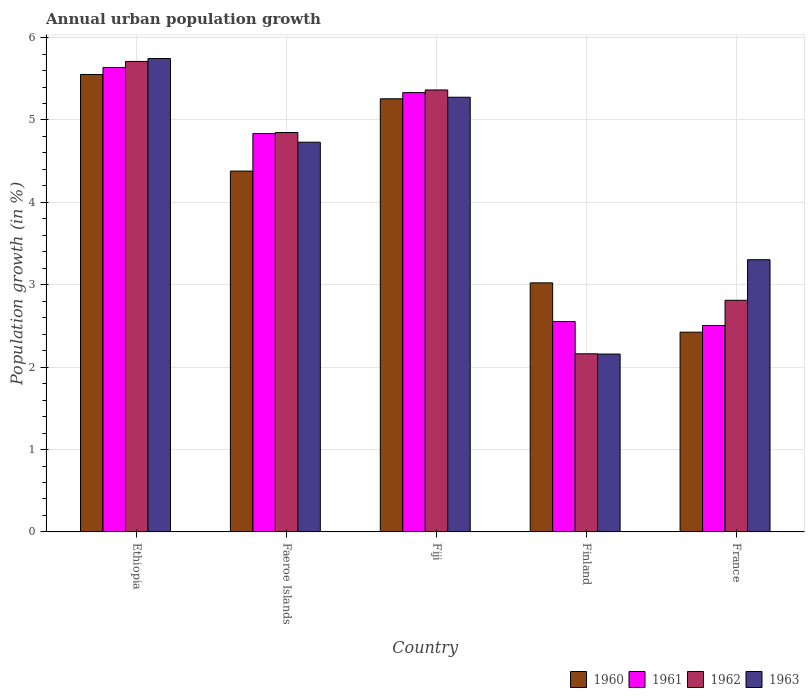How many different coloured bars are there?
Provide a succinct answer. 4. Are the number of bars on each tick of the X-axis equal?
Ensure brevity in your answer.  Yes. How many bars are there on the 4th tick from the left?
Provide a short and direct response. 4. What is the label of the 3rd group of bars from the left?
Ensure brevity in your answer.  Fiji. What is the percentage of urban population growth in 1961 in Fiji?
Provide a short and direct response. 5.33. Across all countries, what is the maximum percentage of urban population growth in 1960?
Provide a succinct answer. 5.55. Across all countries, what is the minimum percentage of urban population growth in 1961?
Make the answer very short. 2.51. In which country was the percentage of urban population growth in 1963 maximum?
Offer a very short reply. Ethiopia. What is the total percentage of urban population growth in 1960 in the graph?
Your answer should be very brief. 20.64. What is the difference between the percentage of urban population growth in 1962 in Fiji and that in Finland?
Ensure brevity in your answer.  3.2. What is the difference between the percentage of urban population growth in 1960 in Ethiopia and the percentage of urban population growth in 1962 in Finland?
Offer a terse response. 3.39. What is the average percentage of urban population growth in 1963 per country?
Ensure brevity in your answer.  4.24. What is the difference between the percentage of urban population growth of/in 1961 and percentage of urban population growth of/in 1960 in Faeroe Islands?
Keep it short and to the point. 0.46. In how many countries, is the percentage of urban population growth in 1961 greater than 0.6000000000000001 %?
Offer a very short reply. 5. What is the ratio of the percentage of urban population growth in 1963 in Faeroe Islands to that in France?
Provide a succinct answer. 1.43. Is the percentage of urban population growth in 1962 in Ethiopia less than that in France?
Make the answer very short. No. Is the difference between the percentage of urban population growth in 1961 in Faeroe Islands and France greater than the difference between the percentage of urban population growth in 1960 in Faeroe Islands and France?
Make the answer very short. Yes. What is the difference between the highest and the second highest percentage of urban population growth in 1963?
Your response must be concise. 0.55. What is the difference between the highest and the lowest percentage of urban population growth in 1960?
Your answer should be compact. 3.13. In how many countries, is the percentage of urban population growth in 1960 greater than the average percentage of urban population growth in 1960 taken over all countries?
Your response must be concise. 3. Is it the case that in every country, the sum of the percentage of urban population growth in 1961 and percentage of urban population growth in 1962 is greater than the sum of percentage of urban population growth in 1960 and percentage of urban population growth in 1963?
Your answer should be very brief. No. How many bars are there?
Offer a terse response. 20. Are all the bars in the graph horizontal?
Your answer should be very brief. No. What is the difference between two consecutive major ticks on the Y-axis?
Provide a succinct answer. 1. Are the values on the major ticks of Y-axis written in scientific E-notation?
Provide a short and direct response. No. Where does the legend appear in the graph?
Provide a succinct answer. Bottom right. What is the title of the graph?
Provide a short and direct response. Annual urban population growth. Does "1970" appear as one of the legend labels in the graph?
Ensure brevity in your answer.  No. What is the label or title of the X-axis?
Provide a short and direct response. Country. What is the label or title of the Y-axis?
Offer a very short reply. Population growth (in %). What is the Population growth (in %) of 1960 in Ethiopia?
Provide a succinct answer. 5.55. What is the Population growth (in %) in 1961 in Ethiopia?
Provide a succinct answer. 5.64. What is the Population growth (in %) of 1962 in Ethiopia?
Provide a short and direct response. 5.71. What is the Population growth (in %) in 1963 in Ethiopia?
Provide a short and direct response. 5.75. What is the Population growth (in %) in 1960 in Faeroe Islands?
Offer a very short reply. 4.38. What is the Population growth (in %) of 1961 in Faeroe Islands?
Provide a short and direct response. 4.84. What is the Population growth (in %) in 1962 in Faeroe Islands?
Provide a short and direct response. 4.85. What is the Population growth (in %) in 1963 in Faeroe Islands?
Ensure brevity in your answer.  4.73. What is the Population growth (in %) of 1960 in Fiji?
Keep it short and to the point. 5.26. What is the Population growth (in %) in 1961 in Fiji?
Your response must be concise. 5.33. What is the Population growth (in %) of 1962 in Fiji?
Your answer should be very brief. 5.36. What is the Population growth (in %) of 1963 in Fiji?
Offer a terse response. 5.28. What is the Population growth (in %) in 1960 in Finland?
Offer a terse response. 3.02. What is the Population growth (in %) of 1961 in Finland?
Provide a short and direct response. 2.55. What is the Population growth (in %) of 1962 in Finland?
Your answer should be compact. 2.16. What is the Population growth (in %) in 1963 in Finland?
Ensure brevity in your answer.  2.16. What is the Population growth (in %) in 1960 in France?
Offer a very short reply. 2.42. What is the Population growth (in %) of 1961 in France?
Offer a terse response. 2.51. What is the Population growth (in %) in 1962 in France?
Give a very brief answer. 2.81. What is the Population growth (in %) of 1963 in France?
Give a very brief answer. 3.3. Across all countries, what is the maximum Population growth (in %) in 1960?
Provide a short and direct response. 5.55. Across all countries, what is the maximum Population growth (in %) of 1961?
Your response must be concise. 5.64. Across all countries, what is the maximum Population growth (in %) of 1962?
Offer a very short reply. 5.71. Across all countries, what is the maximum Population growth (in %) in 1963?
Provide a short and direct response. 5.75. Across all countries, what is the minimum Population growth (in %) of 1960?
Offer a very short reply. 2.42. Across all countries, what is the minimum Population growth (in %) in 1961?
Offer a very short reply. 2.51. Across all countries, what is the minimum Population growth (in %) of 1962?
Your answer should be compact. 2.16. Across all countries, what is the minimum Population growth (in %) in 1963?
Offer a terse response. 2.16. What is the total Population growth (in %) in 1960 in the graph?
Keep it short and to the point. 20.64. What is the total Population growth (in %) in 1961 in the graph?
Provide a succinct answer. 20.86. What is the total Population growth (in %) of 1962 in the graph?
Make the answer very short. 20.9. What is the total Population growth (in %) in 1963 in the graph?
Make the answer very short. 21.22. What is the difference between the Population growth (in %) in 1960 in Ethiopia and that in Faeroe Islands?
Keep it short and to the point. 1.17. What is the difference between the Population growth (in %) in 1961 in Ethiopia and that in Faeroe Islands?
Provide a succinct answer. 0.8. What is the difference between the Population growth (in %) of 1962 in Ethiopia and that in Faeroe Islands?
Offer a very short reply. 0.86. What is the difference between the Population growth (in %) in 1963 in Ethiopia and that in Faeroe Islands?
Give a very brief answer. 1.02. What is the difference between the Population growth (in %) in 1960 in Ethiopia and that in Fiji?
Provide a succinct answer. 0.29. What is the difference between the Population growth (in %) of 1961 in Ethiopia and that in Fiji?
Your response must be concise. 0.31. What is the difference between the Population growth (in %) of 1962 in Ethiopia and that in Fiji?
Offer a terse response. 0.35. What is the difference between the Population growth (in %) in 1963 in Ethiopia and that in Fiji?
Keep it short and to the point. 0.47. What is the difference between the Population growth (in %) of 1960 in Ethiopia and that in Finland?
Provide a short and direct response. 2.53. What is the difference between the Population growth (in %) in 1961 in Ethiopia and that in Finland?
Keep it short and to the point. 3.08. What is the difference between the Population growth (in %) in 1962 in Ethiopia and that in Finland?
Offer a terse response. 3.55. What is the difference between the Population growth (in %) of 1963 in Ethiopia and that in Finland?
Provide a short and direct response. 3.59. What is the difference between the Population growth (in %) in 1960 in Ethiopia and that in France?
Your answer should be very brief. 3.13. What is the difference between the Population growth (in %) of 1961 in Ethiopia and that in France?
Keep it short and to the point. 3.13. What is the difference between the Population growth (in %) of 1962 in Ethiopia and that in France?
Keep it short and to the point. 2.9. What is the difference between the Population growth (in %) of 1963 in Ethiopia and that in France?
Keep it short and to the point. 2.44. What is the difference between the Population growth (in %) in 1960 in Faeroe Islands and that in Fiji?
Your response must be concise. -0.88. What is the difference between the Population growth (in %) in 1961 in Faeroe Islands and that in Fiji?
Offer a terse response. -0.5. What is the difference between the Population growth (in %) of 1962 in Faeroe Islands and that in Fiji?
Provide a succinct answer. -0.52. What is the difference between the Population growth (in %) in 1963 in Faeroe Islands and that in Fiji?
Give a very brief answer. -0.55. What is the difference between the Population growth (in %) of 1960 in Faeroe Islands and that in Finland?
Provide a succinct answer. 1.36. What is the difference between the Population growth (in %) of 1961 in Faeroe Islands and that in Finland?
Ensure brevity in your answer.  2.28. What is the difference between the Population growth (in %) of 1962 in Faeroe Islands and that in Finland?
Ensure brevity in your answer.  2.69. What is the difference between the Population growth (in %) of 1963 in Faeroe Islands and that in Finland?
Keep it short and to the point. 2.57. What is the difference between the Population growth (in %) of 1960 in Faeroe Islands and that in France?
Offer a terse response. 1.96. What is the difference between the Population growth (in %) of 1961 in Faeroe Islands and that in France?
Your answer should be compact. 2.33. What is the difference between the Population growth (in %) of 1962 in Faeroe Islands and that in France?
Offer a very short reply. 2.04. What is the difference between the Population growth (in %) in 1963 in Faeroe Islands and that in France?
Provide a short and direct response. 1.43. What is the difference between the Population growth (in %) of 1960 in Fiji and that in Finland?
Provide a succinct answer. 2.23. What is the difference between the Population growth (in %) in 1961 in Fiji and that in Finland?
Provide a short and direct response. 2.78. What is the difference between the Population growth (in %) of 1962 in Fiji and that in Finland?
Give a very brief answer. 3.2. What is the difference between the Population growth (in %) of 1963 in Fiji and that in Finland?
Make the answer very short. 3.12. What is the difference between the Population growth (in %) of 1960 in Fiji and that in France?
Your answer should be compact. 2.83. What is the difference between the Population growth (in %) of 1961 in Fiji and that in France?
Provide a short and direct response. 2.83. What is the difference between the Population growth (in %) in 1962 in Fiji and that in France?
Provide a short and direct response. 2.55. What is the difference between the Population growth (in %) in 1963 in Fiji and that in France?
Your answer should be very brief. 1.97. What is the difference between the Population growth (in %) in 1960 in Finland and that in France?
Ensure brevity in your answer.  0.6. What is the difference between the Population growth (in %) in 1961 in Finland and that in France?
Offer a very short reply. 0.05. What is the difference between the Population growth (in %) of 1962 in Finland and that in France?
Make the answer very short. -0.65. What is the difference between the Population growth (in %) of 1963 in Finland and that in France?
Provide a succinct answer. -1.15. What is the difference between the Population growth (in %) of 1960 in Ethiopia and the Population growth (in %) of 1961 in Faeroe Islands?
Make the answer very short. 0.72. What is the difference between the Population growth (in %) of 1960 in Ethiopia and the Population growth (in %) of 1962 in Faeroe Islands?
Your response must be concise. 0.7. What is the difference between the Population growth (in %) in 1960 in Ethiopia and the Population growth (in %) in 1963 in Faeroe Islands?
Offer a terse response. 0.82. What is the difference between the Population growth (in %) of 1961 in Ethiopia and the Population growth (in %) of 1962 in Faeroe Islands?
Your response must be concise. 0.79. What is the difference between the Population growth (in %) of 1961 in Ethiopia and the Population growth (in %) of 1963 in Faeroe Islands?
Your response must be concise. 0.91. What is the difference between the Population growth (in %) of 1962 in Ethiopia and the Population growth (in %) of 1963 in Faeroe Islands?
Give a very brief answer. 0.98. What is the difference between the Population growth (in %) of 1960 in Ethiopia and the Population growth (in %) of 1961 in Fiji?
Ensure brevity in your answer.  0.22. What is the difference between the Population growth (in %) of 1960 in Ethiopia and the Population growth (in %) of 1962 in Fiji?
Give a very brief answer. 0.19. What is the difference between the Population growth (in %) of 1960 in Ethiopia and the Population growth (in %) of 1963 in Fiji?
Your response must be concise. 0.28. What is the difference between the Population growth (in %) of 1961 in Ethiopia and the Population growth (in %) of 1962 in Fiji?
Your response must be concise. 0.27. What is the difference between the Population growth (in %) of 1961 in Ethiopia and the Population growth (in %) of 1963 in Fiji?
Keep it short and to the point. 0.36. What is the difference between the Population growth (in %) in 1962 in Ethiopia and the Population growth (in %) in 1963 in Fiji?
Provide a succinct answer. 0.43. What is the difference between the Population growth (in %) in 1960 in Ethiopia and the Population growth (in %) in 1961 in Finland?
Offer a terse response. 3. What is the difference between the Population growth (in %) in 1960 in Ethiopia and the Population growth (in %) in 1962 in Finland?
Your answer should be compact. 3.39. What is the difference between the Population growth (in %) of 1960 in Ethiopia and the Population growth (in %) of 1963 in Finland?
Ensure brevity in your answer.  3.39. What is the difference between the Population growth (in %) of 1961 in Ethiopia and the Population growth (in %) of 1962 in Finland?
Your answer should be compact. 3.48. What is the difference between the Population growth (in %) in 1961 in Ethiopia and the Population growth (in %) in 1963 in Finland?
Provide a short and direct response. 3.48. What is the difference between the Population growth (in %) of 1962 in Ethiopia and the Population growth (in %) of 1963 in Finland?
Provide a short and direct response. 3.55. What is the difference between the Population growth (in %) in 1960 in Ethiopia and the Population growth (in %) in 1961 in France?
Your answer should be compact. 3.05. What is the difference between the Population growth (in %) in 1960 in Ethiopia and the Population growth (in %) in 1962 in France?
Your response must be concise. 2.74. What is the difference between the Population growth (in %) in 1960 in Ethiopia and the Population growth (in %) in 1963 in France?
Provide a succinct answer. 2.25. What is the difference between the Population growth (in %) in 1961 in Ethiopia and the Population growth (in %) in 1962 in France?
Your answer should be compact. 2.83. What is the difference between the Population growth (in %) of 1961 in Ethiopia and the Population growth (in %) of 1963 in France?
Keep it short and to the point. 2.33. What is the difference between the Population growth (in %) in 1962 in Ethiopia and the Population growth (in %) in 1963 in France?
Ensure brevity in your answer.  2.41. What is the difference between the Population growth (in %) of 1960 in Faeroe Islands and the Population growth (in %) of 1961 in Fiji?
Offer a terse response. -0.95. What is the difference between the Population growth (in %) in 1960 in Faeroe Islands and the Population growth (in %) in 1962 in Fiji?
Give a very brief answer. -0.98. What is the difference between the Population growth (in %) of 1960 in Faeroe Islands and the Population growth (in %) of 1963 in Fiji?
Provide a succinct answer. -0.9. What is the difference between the Population growth (in %) of 1961 in Faeroe Islands and the Population growth (in %) of 1962 in Fiji?
Offer a very short reply. -0.53. What is the difference between the Population growth (in %) in 1961 in Faeroe Islands and the Population growth (in %) in 1963 in Fiji?
Give a very brief answer. -0.44. What is the difference between the Population growth (in %) in 1962 in Faeroe Islands and the Population growth (in %) in 1963 in Fiji?
Offer a very short reply. -0.43. What is the difference between the Population growth (in %) in 1960 in Faeroe Islands and the Population growth (in %) in 1961 in Finland?
Give a very brief answer. 1.83. What is the difference between the Population growth (in %) in 1960 in Faeroe Islands and the Population growth (in %) in 1962 in Finland?
Ensure brevity in your answer.  2.22. What is the difference between the Population growth (in %) in 1960 in Faeroe Islands and the Population growth (in %) in 1963 in Finland?
Your answer should be compact. 2.22. What is the difference between the Population growth (in %) of 1961 in Faeroe Islands and the Population growth (in %) of 1962 in Finland?
Your answer should be very brief. 2.67. What is the difference between the Population growth (in %) of 1961 in Faeroe Islands and the Population growth (in %) of 1963 in Finland?
Make the answer very short. 2.68. What is the difference between the Population growth (in %) in 1962 in Faeroe Islands and the Population growth (in %) in 1963 in Finland?
Keep it short and to the point. 2.69. What is the difference between the Population growth (in %) of 1960 in Faeroe Islands and the Population growth (in %) of 1961 in France?
Your answer should be compact. 1.87. What is the difference between the Population growth (in %) of 1960 in Faeroe Islands and the Population growth (in %) of 1962 in France?
Ensure brevity in your answer.  1.57. What is the difference between the Population growth (in %) of 1960 in Faeroe Islands and the Population growth (in %) of 1963 in France?
Keep it short and to the point. 1.08. What is the difference between the Population growth (in %) in 1961 in Faeroe Islands and the Population growth (in %) in 1962 in France?
Offer a terse response. 2.02. What is the difference between the Population growth (in %) of 1961 in Faeroe Islands and the Population growth (in %) of 1963 in France?
Make the answer very short. 1.53. What is the difference between the Population growth (in %) in 1962 in Faeroe Islands and the Population growth (in %) in 1963 in France?
Keep it short and to the point. 1.54. What is the difference between the Population growth (in %) in 1960 in Fiji and the Population growth (in %) in 1961 in Finland?
Make the answer very short. 2.7. What is the difference between the Population growth (in %) in 1960 in Fiji and the Population growth (in %) in 1962 in Finland?
Ensure brevity in your answer.  3.1. What is the difference between the Population growth (in %) of 1960 in Fiji and the Population growth (in %) of 1963 in Finland?
Give a very brief answer. 3.1. What is the difference between the Population growth (in %) of 1961 in Fiji and the Population growth (in %) of 1962 in Finland?
Keep it short and to the point. 3.17. What is the difference between the Population growth (in %) of 1961 in Fiji and the Population growth (in %) of 1963 in Finland?
Your answer should be very brief. 3.17. What is the difference between the Population growth (in %) in 1962 in Fiji and the Population growth (in %) in 1963 in Finland?
Your answer should be compact. 3.21. What is the difference between the Population growth (in %) of 1960 in Fiji and the Population growth (in %) of 1961 in France?
Your answer should be very brief. 2.75. What is the difference between the Population growth (in %) in 1960 in Fiji and the Population growth (in %) in 1962 in France?
Your answer should be very brief. 2.45. What is the difference between the Population growth (in %) of 1960 in Fiji and the Population growth (in %) of 1963 in France?
Your answer should be very brief. 1.95. What is the difference between the Population growth (in %) of 1961 in Fiji and the Population growth (in %) of 1962 in France?
Your answer should be very brief. 2.52. What is the difference between the Population growth (in %) of 1961 in Fiji and the Population growth (in %) of 1963 in France?
Make the answer very short. 2.03. What is the difference between the Population growth (in %) in 1962 in Fiji and the Population growth (in %) in 1963 in France?
Offer a terse response. 2.06. What is the difference between the Population growth (in %) of 1960 in Finland and the Population growth (in %) of 1961 in France?
Make the answer very short. 0.52. What is the difference between the Population growth (in %) in 1960 in Finland and the Population growth (in %) in 1962 in France?
Keep it short and to the point. 0.21. What is the difference between the Population growth (in %) in 1960 in Finland and the Population growth (in %) in 1963 in France?
Give a very brief answer. -0.28. What is the difference between the Population growth (in %) of 1961 in Finland and the Population growth (in %) of 1962 in France?
Your answer should be compact. -0.26. What is the difference between the Population growth (in %) of 1961 in Finland and the Population growth (in %) of 1963 in France?
Keep it short and to the point. -0.75. What is the difference between the Population growth (in %) in 1962 in Finland and the Population growth (in %) in 1963 in France?
Your response must be concise. -1.14. What is the average Population growth (in %) of 1960 per country?
Provide a short and direct response. 4.13. What is the average Population growth (in %) in 1961 per country?
Make the answer very short. 4.17. What is the average Population growth (in %) in 1962 per country?
Offer a very short reply. 4.18. What is the average Population growth (in %) in 1963 per country?
Give a very brief answer. 4.24. What is the difference between the Population growth (in %) of 1960 and Population growth (in %) of 1961 in Ethiopia?
Ensure brevity in your answer.  -0.09. What is the difference between the Population growth (in %) in 1960 and Population growth (in %) in 1962 in Ethiopia?
Offer a very short reply. -0.16. What is the difference between the Population growth (in %) in 1960 and Population growth (in %) in 1963 in Ethiopia?
Give a very brief answer. -0.19. What is the difference between the Population growth (in %) of 1961 and Population growth (in %) of 1962 in Ethiopia?
Make the answer very short. -0.07. What is the difference between the Population growth (in %) in 1961 and Population growth (in %) in 1963 in Ethiopia?
Provide a succinct answer. -0.11. What is the difference between the Population growth (in %) of 1962 and Population growth (in %) of 1963 in Ethiopia?
Provide a succinct answer. -0.04. What is the difference between the Population growth (in %) of 1960 and Population growth (in %) of 1961 in Faeroe Islands?
Your answer should be compact. -0.46. What is the difference between the Population growth (in %) in 1960 and Population growth (in %) in 1962 in Faeroe Islands?
Your answer should be very brief. -0.47. What is the difference between the Population growth (in %) in 1960 and Population growth (in %) in 1963 in Faeroe Islands?
Ensure brevity in your answer.  -0.35. What is the difference between the Population growth (in %) in 1961 and Population growth (in %) in 1962 in Faeroe Islands?
Ensure brevity in your answer.  -0.01. What is the difference between the Population growth (in %) in 1961 and Population growth (in %) in 1963 in Faeroe Islands?
Your answer should be compact. 0.11. What is the difference between the Population growth (in %) of 1962 and Population growth (in %) of 1963 in Faeroe Islands?
Give a very brief answer. 0.12. What is the difference between the Population growth (in %) of 1960 and Population growth (in %) of 1961 in Fiji?
Give a very brief answer. -0.07. What is the difference between the Population growth (in %) in 1960 and Population growth (in %) in 1962 in Fiji?
Give a very brief answer. -0.11. What is the difference between the Population growth (in %) in 1960 and Population growth (in %) in 1963 in Fiji?
Your response must be concise. -0.02. What is the difference between the Population growth (in %) in 1961 and Population growth (in %) in 1962 in Fiji?
Provide a short and direct response. -0.03. What is the difference between the Population growth (in %) of 1961 and Population growth (in %) of 1963 in Fiji?
Your answer should be compact. 0.06. What is the difference between the Population growth (in %) in 1962 and Population growth (in %) in 1963 in Fiji?
Offer a terse response. 0.09. What is the difference between the Population growth (in %) in 1960 and Population growth (in %) in 1961 in Finland?
Offer a terse response. 0.47. What is the difference between the Population growth (in %) of 1960 and Population growth (in %) of 1962 in Finland?
Offer a very short reply. 0.86. What is the difference between the Population growth (in %) in 1960 and Population growth (in %) in 1963 in Finland?
Offer a terse response. 0.86. What is the difference between the Population growth (in %) in 1961 and Population growth (in %) in 1962 in Finland?
Your response must be concise. 0.39. What is the difference between the Population growth (in %) in 1961 and Population growth (in %) in 1963 in Finland?
Offer a terse response. 0.39. What is the difference between the Population growth (in %) of 1962 and Population growth (in %) of 1963 in Finland?
Give a very brief answer. 0. What is the difference between the Population growth (in %) of 1960 and Population growth (in %) of 1961 in France?
Ensure brevity in your answer.  -0.08. What is the difference between the Population growth (in %) of 1960 and Population growth (in %) of 1962 in France?
Your response must be concise. -0.39. What is the difference between the Population growth (in %) in 1960 and Population growth (in %) in 1963 in France?
Your answer should be very brief. -0.88. What is the difference between the Population growth (in %) in 1961 and Population growth (in %) in 1962 in France?
Make the answer very short. -0.31. What is the difference between the Population growth (in %) in 1961 and Population growth (in %) in 1963 in France?
Keep it short and to the point. -0.8. What is the difference between the Population growth (in %) of 1962 and Population growth (in %) of 1963 in France?
Offer a very short reply. -0.49. What is the ratio of the Population growth (in %) of 1960 in Ethiopia to that in Faeroe Islands?
Offer a very short reply. 1.27. What is the ratio of the Population growth (in %) in 1961 in Ethiopia to that in Faeroe Islands?
Provide a short and direct response. 1.17. What is the ratio of the Population growth (in %) in 1962 in Ethiopia to that in Faeroe Islands?
Your answer should be compact. 1.18. What is the ratio of the Population growth (in %) of 1963 in Ethiopia to that in Faeroe Islands?
Offer a very short reply. 1.21. What is the ratio of the Population growth (in %) of 1960 in Ethiopia to that in Fiji?
Provide a succinct answer. 1.06. What is the ratio of the Population growth (in %) in 1961 in Ethiopia to that in Fiji?
Keep it short and to the point. 1.06. What is the ratio of the Population growth (in %) in 1962 in Ethiopia to that in Fiji?
Ensure brevity in your answer.  1.06. What is the ratio of the Population growth (in %) in 1963 in Ethiopia to that in Fiji?
Your answer should be very brief. 1.09. What is the ratio of the Population growth (in %) of 1960 in Ethiopia to that in Finland?
Ensure brevity in your answer.  1.84. What is the ratio of the Population growth (in %) in 1961 in Ethiopia to that in Finland?
Offer a very short reply. 2.21. What is the ratio of the Population growth (in %) in 1962 in Ethiopia to that in Finland?
Provide a succinct answer. 2.64. What is the ratio of the Population growth (in %) of 1963 in Ethiopia to that in Finland?
Provide a succinct answer. 2.66. What is the ratio of the Population growth (in %) of 1960 in Ethiopia to that in France?
Your answer should be very brief. 2.29. What is the ratio of the Population growth (in %) of 1961 in Ethiopia to that in France?
Make the answer very short. 2.25. What is the ratio of the Population growth (in %) in 1962 in Ethiopia to that in France?
Provide a short and direct response. 2.03. What is the ratio of the Population growth (in %) in 1963 in Ethiopia to that in France?
Provide a succinct answer. 1.74. What is the ratio of the Population growth (in %) of 1960 in Faeroe Islands to that in Fiji?
Offer a terse response. 0.83. What is the ratio of the Population growth (in %) of 1961 in Faeroe Islands to that in Fiji?
Offer a terse response. 0.91. What is the ratio of the Population growth (in %) of 1962 in Faeroe Islands to that in Fiji?
Provide a short and direct response. 0.9. What is the ratio of the Population growth (in %) in 1963 in Faeroe Islands to that in Fiji?
Give a very brief answer. 0.9. What is the ratio of the Population growth (in %) of 1960 in Faeroe Islands to that in Finland?
Provide a short and direct response. 1.45. What is the ratio of the Population growth (in %) of 1961 in Faeroe Islands to that in Finland?
Provide a short and direct response. 1.89. What is the ratio of the Population growth (in %) in 1962 in Faeroe Islands to that in Finland?
Give a very brief answer. 2.24. What is the ratio of the Population growth (in %) in 1963 in Faeroe Islands to that in Finland?
Provide a short and direct response. 2.19. What is the ratio of the Population growth (in %) of 1960 in Faeroe Islands to that in France?
Offer a very short reply. 1.81. What is the ratio of the Population growth (in %) in 1961 in Faeroe Islands to that in France?
Provide a succinct answer. 1.93. What is the ratio of the Population growth (in %) in 1962 in Faeroe Islands to that in France?
Provide a succinct answer. 1.72. What is the ratio of the Population growth (in %) of 1963 in Faeroe Islands to that in France?
Your answer should be compact. 1.43. What is the ratio of the Population growth (in %) in 1960 in Fiji to that in Finland?
Offer a terse response. 1.74. What is the ratio of the Population growth (in %) in 1961 in Fiji to that in Finland?
Your answer should be compact. 2.09. What is the ratio of the Population growth (in %) of 1962 in Fiji to that in Finland?
Keep it short and to the point. 2.48. What is the ratio of the Population growth (in %) of 1963 in Fiji to that in Finland?
Your answer should be very brief. 2.44. What is the ratio of the Population growth (in %) in 1960 in Fiji to that in France?
Your answer should be compact. 2.17. What is the ratio of the Population growth (in %) of 1961 in Fiji to that in France?
Give a very brief answer. 2.13. What is the ratio of the Population growth (in %) of 1962 in Fiji to that in France?
Your answer should be compact. 1.91. What is the ratio of the Population growth (in %) in 1963 in Fiji to that in France?
Your answer should be compact. 1.6. What is the ratio of the Population growth (in %) of 1960 in Finland to that in France?
Offer a terse response. 1.25. What is the ratio of the Population growth (in %) in 1961 in Finland to that in France?
Offer a terse response. 1.02. What is the ratio of the Population growth (in %) in 1962 in Finland to that in France?
Provide a short and direct response. 0.77. What is the ratio of the Population growth (in %) in 1963 in Finland to that in France?
Your answer should be very brief. 0.65. What is the difference between the highest and the second highest Population growth (in %) of 1960?
Offer a terse response. 0.29. What is the difference between the highest and the second highest Population growth (in %) in 1961?
Ensure brevity in your answer.  0.31. What is the difference between the highest and the second highest Population growth (in %) in 1962?
Keep it short and to the point. 0.35. What is the difference between the highest and the second highest Population growth (in %) of 1963?
Your answer should be very brief. 0.47. What is the difference between the highest and the lowest Population growth (in %) of 1960?
Make the answer very short. 3.13. What is the difference between the highest and the lowest Population growth (in %) of 1961?
Keep it short and to the point. 3.13. What is the difference between the highest and the lowest Population growth (in %) of 1962?
Make the answer very short. 3.55. What is the difference between the highest and the lowest Population growth (in %) in 1963?
Offer a terse response. 3.59. 